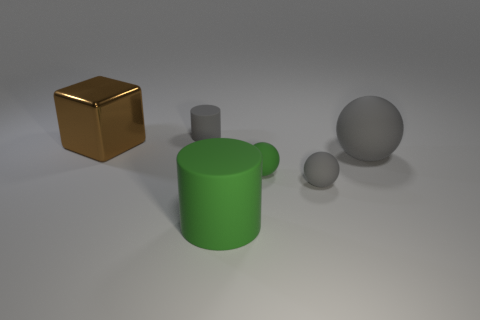The lighting in the scene suggests a particular time of day or setting. Can you describe it? The lighting in the scene appears soft and diffuse, with no hard shadows or bright highlights, suggesting an indoor setting with ambient, controlled lighting, rather than a specific time of day. It is evocative of a studio setting where the light is designed to be uniform and flat to avoid distractions and focus on the object's shapes and materials. 